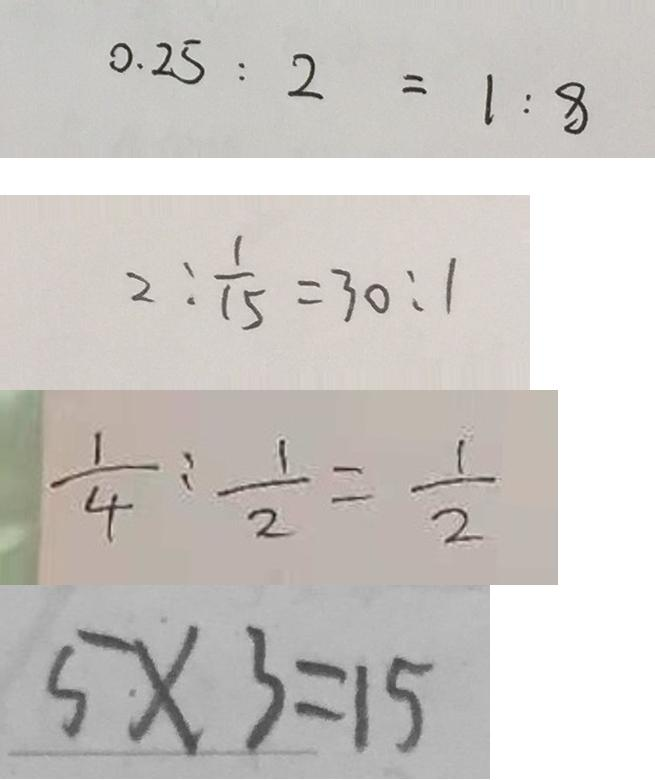Convert formula to latex. <formula><loc_0><loc_0><loc_500><loc_500>0 . 2 5 : 2 = 1 : 8 
 2 : \frac { 1 } { 1 5 } = 3 0 : 1 
 \frac { 1 } { 4 } : \frac { 1 } { 2 } = \frac { 1 } { 2 } 
 5 \cdot \times 3 = 1 5</formula> 